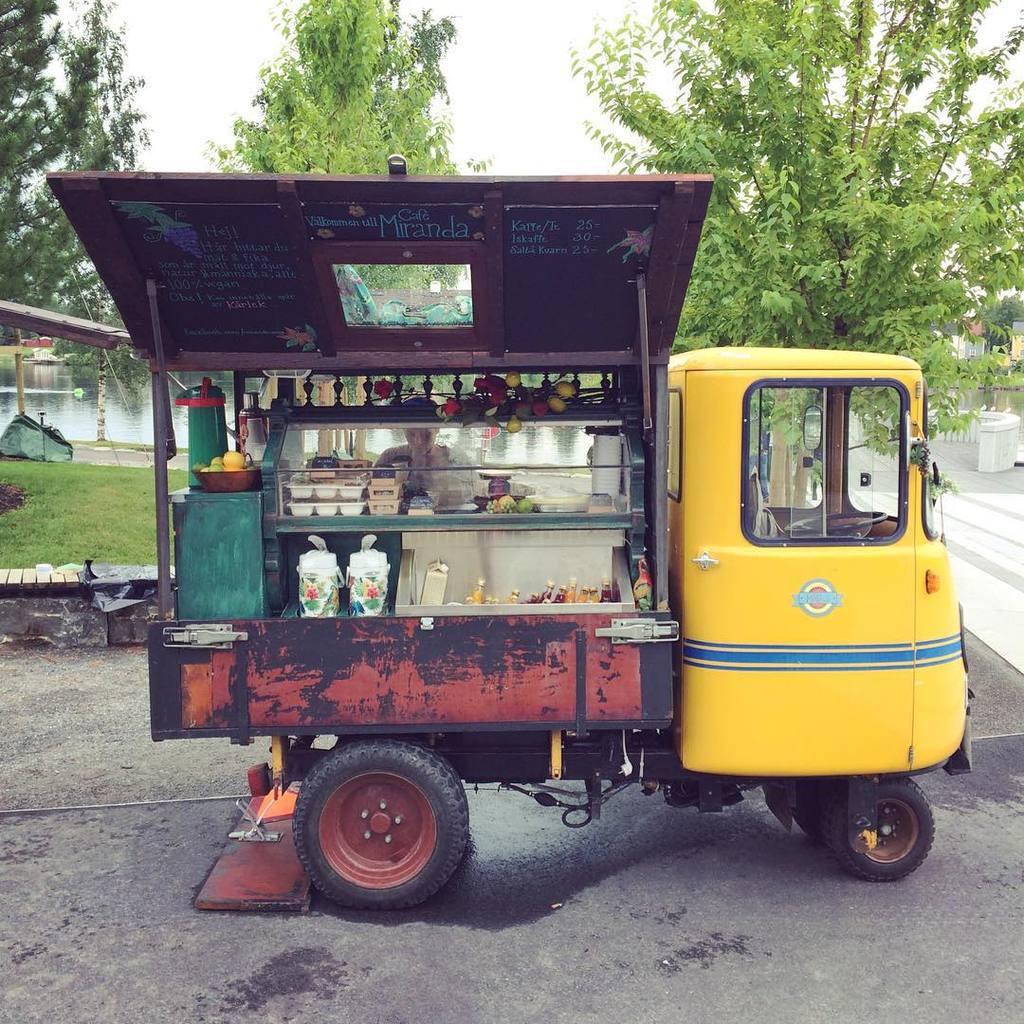Can you describe this image briefly? In this picture I can see the vehicle on the surface. I can see green grass. I can see trees. I can see plastic plates and bottles. 